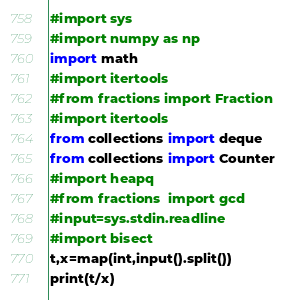Convert code to text. <code><loc_0><loc_0><loc_500><loc_500><_Python_>#import sys
#import numpy as np
import math
#import itertools
#from fractions import Fraction
#import itertools
from collections import deque
from collections import Counter
#import heapq
#from fractions  import gcd
#input=sys.stdin.readline
#import bisect
t,x=map(int,input().split())
print(t/x)</code> 